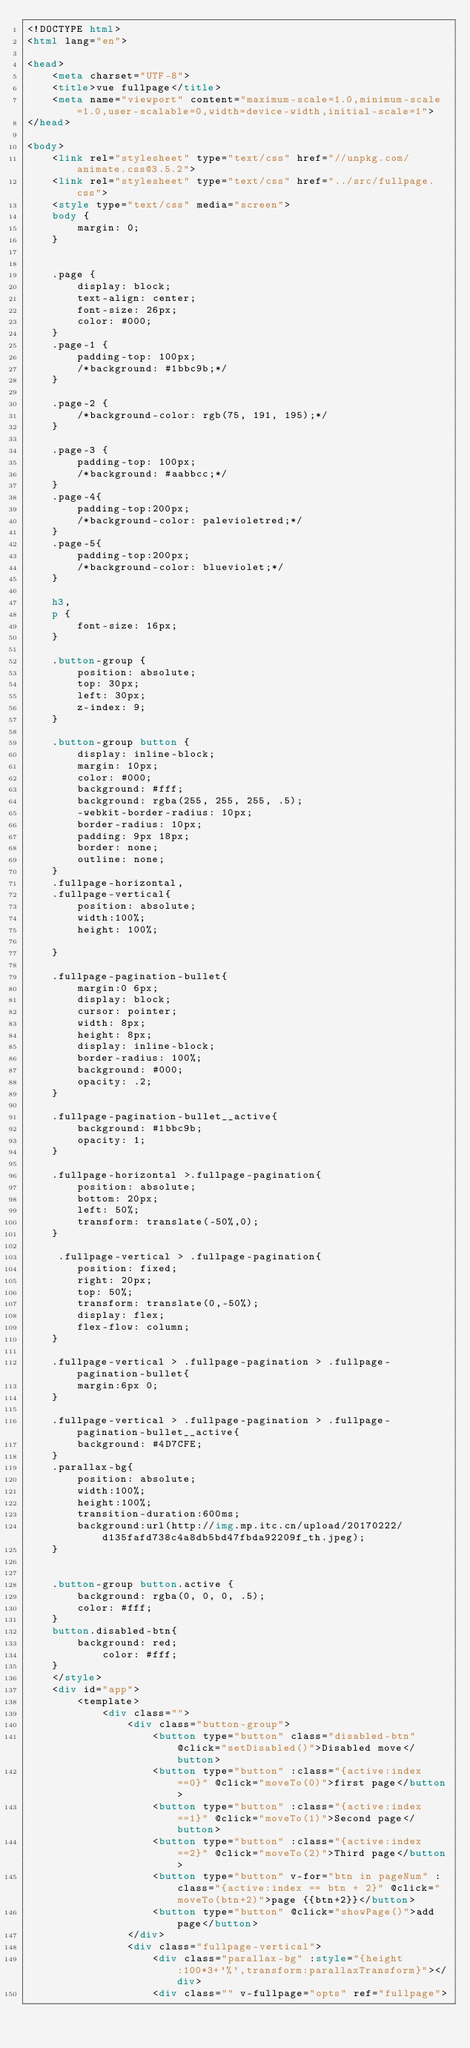Convert code to text. <code><loc_0><loc_0><loc_500><loc_500><_HTML_><!DOCTYPE html>
<html lang="en">

<head>
    <meta charset="UTF-8">
    <title>vue fullpage</title>
    <meta name="viewport" content="maximum-scale=1.0,minimum-scale=1.0,user-scalable=0,width=device-width,initial-scale=1">
</head>

<body>
    <link rel="stylesheet" type="text/css" href="//unpkg.com/animate.css@3.5.2">
    <link rel="stylesheet" type="text/css" href="../src/fullpage.css">
    <style type="text/css" media="screen">
    body {
        margin: 0;
    }


    .page {
        display: block;
        text-align: center;
        font-size: 26px;
        color: #000;
    }
    .page-1 {
        padding-top: 100px;
        /*background: #1bbc9b;*/
    }

    .page-2 {
        /*background-color: rgb(75, 191, 195);*/
    }

    .page-3 {
        padding-top: 100px;
        /*background: #aabbcc;*/
    }
    .page-4{
        padding-top:200px;
        /*background-color: palevioletred;*/
    }
    .page-5{
        padding-top:200px;
        /*background-color: blueviolet;*/
    }

    h3,
    p {
        font-size: 16px;
    }

    .button-group {
        position: absolute;
        top: 30px;
        left: 30px;
        z-index: 9;
    }

    .button-group button {
        display: inline-block;
        margin: 10px;
        color: #000;
        background: #fff;
        background: rgba(255, 255, 255, .5);
        -webkit-border-radius: 10px;
        border-radius: 10px;
        padding: 9px 18px;
        border: none;
        outline: none;
    }
    .fullpage-horizontal,
    .fullpage-vertical{
        position: absolute;
        width:100%;
        height: 100%;

    }

    .fullpage-pagination-bullet{
        margin:0 6px;
        display: block;
        cursor: pointer;
        width: 8px;
        height: 8px;
        display: inline-block;
        border-radius: 100%;
        background: #000;
        opacity: .2;
    }

    .fullpage-pagination-bullet__active{
        background: #1bbc9b;
        opacity: 1;
    }

    .fullpage-horizontal >.fullpage-pagination{
        position: absolute;
        bottom: 20px;
        left: 50%;
        transform: translate(-50%,0);
    }

     .fullpage-vertical > .fullpage-pagination{
        position: fixed;
        right: 20px;
        top: 50%;
        transform: translate(0,-50%);
        display: flex;
        flex-flow: column;
    }

    .fullpage-vertical > .fullpage-pagination > .fullpage-pagination-bullet{
        margin:6px 0;
    }

    .fullpage-vertical > .fullpage-pagination > .fullpage-pagination-bullet__active{
        background: #4D7CFE;    
    }
    .parallax-bg{
        position: absolute;
        width:100%;
        height:100%;
        transition-duration:600ms;
        background:url(http://img.mp.itc.cn/upload/20170222/d135fafd738c4a8db5bd47fbda92209f_th.jpeg);
    }
    

    .button-group button.active {
        background: rgba(0, 0, 0, .5);
        color: #fff;
    }
    button.disabled-btn{
        background: red;
            color: #fff;
    }
    </style>
    <div id="app">
        <template>
            <div class="">
                <div class="button-group">
                    <button type="button" class="disabled-btn" @click="setDisabled()">Disabled move</button>
                    <button type="button" :class="{active:index ==0}" @click="moveTo(0)">first page</button>
                    <button type="button" :class="{active:index ==1}" @click="moveTo(1)">Second page</button>
                    <button type="button" :class="{active:index ==2}" @click="moveTo(2)">Third page</button>
                    <button type="button" v-for="btn in pageNum" :class="{active:index == btn + 2}" @click="moveTo(btn+2)">page {{btn+2}}</button>
                    <button type="button" @click="showPage()">add page</button>
                </div>
                <div class="fullpage-vertical">
                    <div class="parallax-bg" :style="{height:100*3+'%',transform:parallaxTransform}"></div>
                    <div class="" v-fullpage="opts" ref="fullpage"></code> 